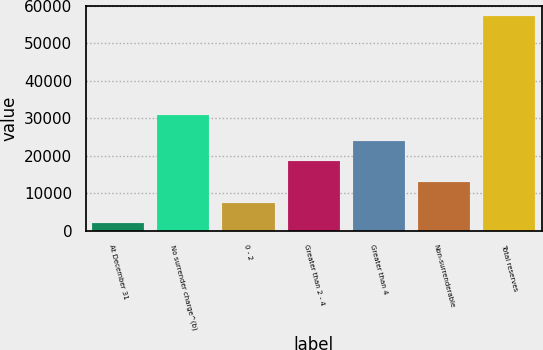Convert chart. <chart><loc_0><loc_0><loc_500><loc_500><bar_chart><fcel>At December 31<fcel>No surrender charge^(b)<fcel>0 - 2<fcel>Greater than 2 - 4<fcel>Greater than 4<fcel>Non-surrenderable<fcel>Total reserves<nl><fcel>2013<fcel>30906<fcel>7528.6<fcel>18559.8<fcel>24075.4<fcel>13044.2<fcel>57169<nl></chart> 